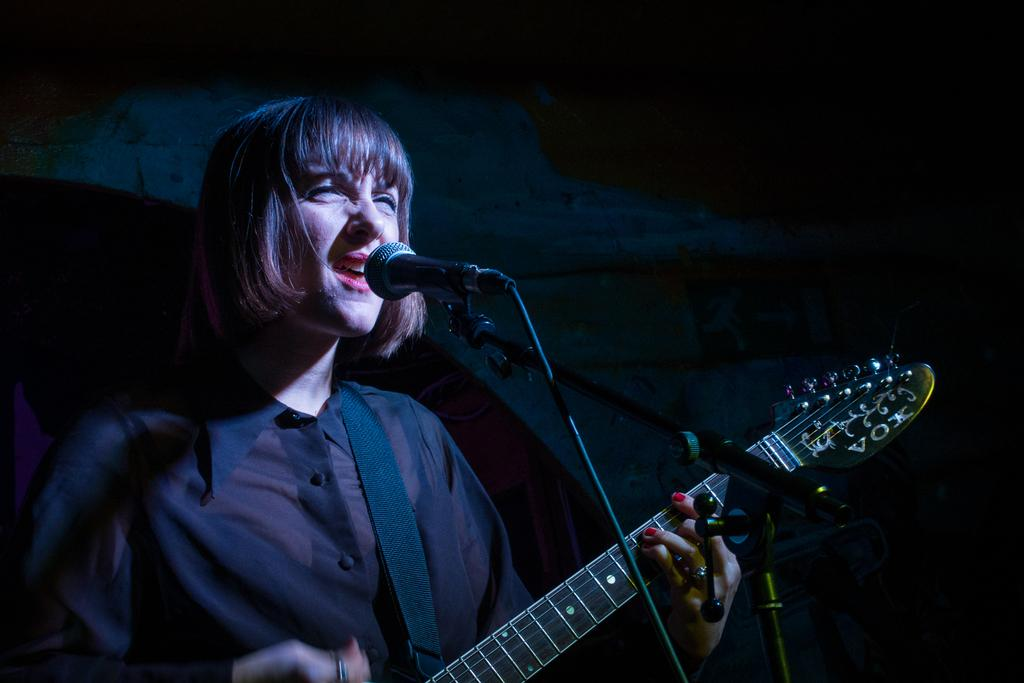What is the girl in the image doing? The girl is playing a guitar in the image. What object is present in the image that is commonly used for amplifying sound? There is a microphone in the image. How many times does the lift go up and down in the image? There is no lift present in the image. What type of clover is growing near the guitar in the image? There is no clover present in the image. 